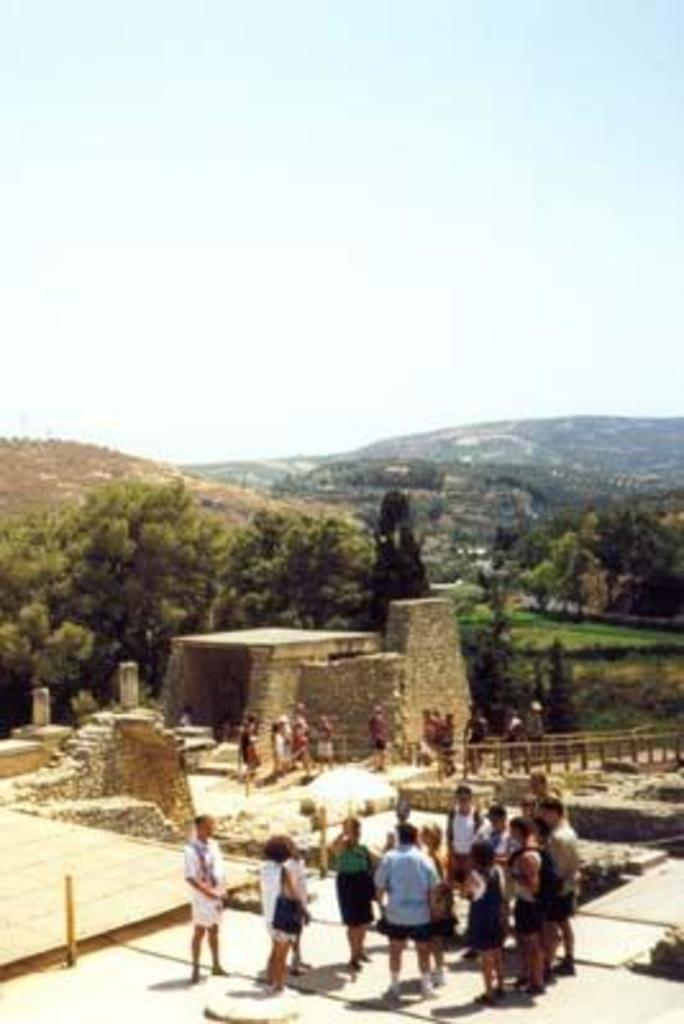Who or what can be seen in the image? There are people in the image. What is the barrier or divider in the image? There is a fence in the image. What type of natural environment is depicted in the image? There is a forest and trees in the image. What geographical feature is present in the image? There is a mountain in the image. What is visible in the background of the image? The sky is visible in the background of the image. Can you find the receipt for the hose purchase in the image? There is no receipt or hose present in the image. 